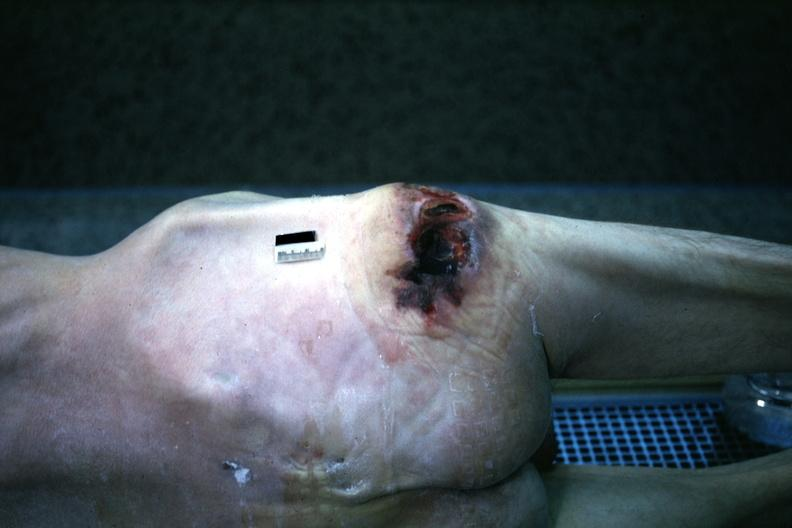what is present?
Answer the question using a single word or phrase. Decubitus ulcer 